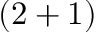Convert formula to latex. <formula><loc_0><loc_0><loc_500><loc_500>( 2 + 1 )</formula> 